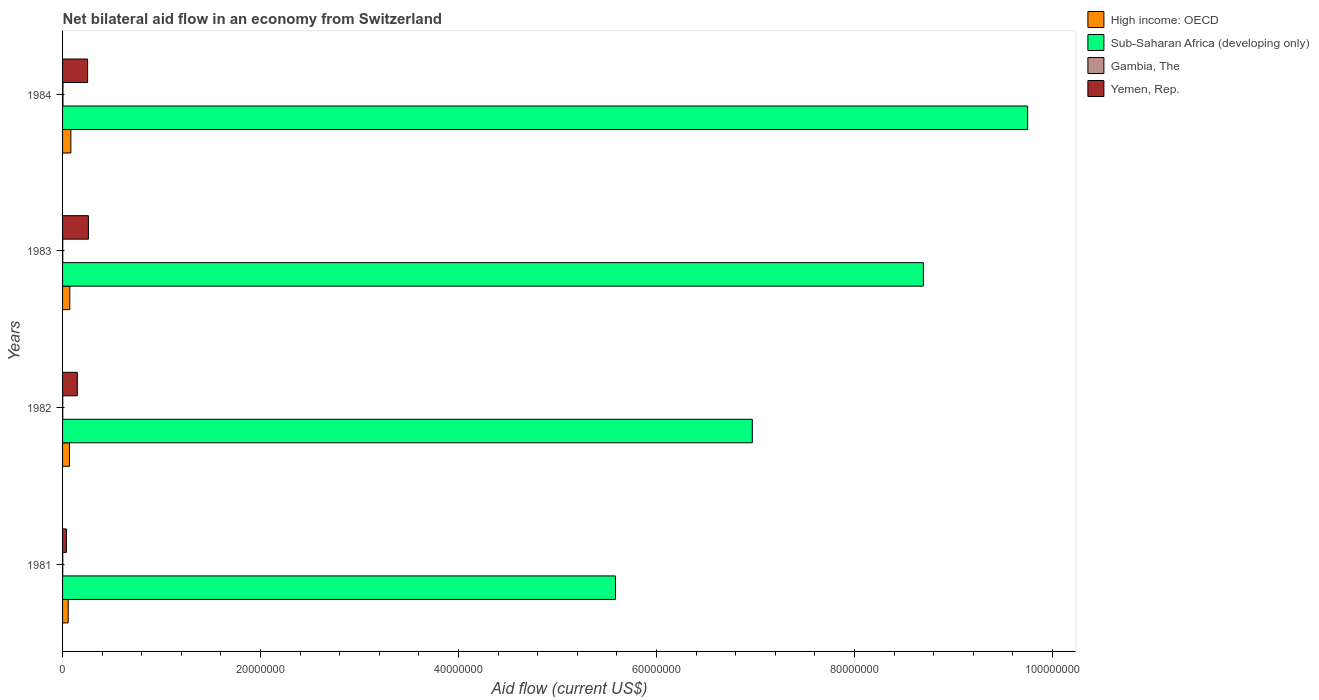How many groups of bars are there?
Provide a succinct answer. 4. Are the number of bars per tick equal to the number of legend labels?
Provide a short and direct response. Yes. Are the number of bars on each tick of the Y-axis equal?
Your answer should be very brief. Yes. How many bars are there on the 4th tick from the bottom?
Give a very brief answer. 4. What is the net bilateral aid flow in Sub-Saharan Africa (developing only) in 1982?
Keep it short and to the point. 6.97e+07. Across all years, what is the maximum net bilateral aid flow in Sub-Saharan Africa (developing only)?
Provide a succinct answer. 9.75e+07. Across all years, what is the minimum net bilateral aid flow in Sub-Saharan Africa (developing only)?
Give a very brief answer. 5.58e+07. In which year was the net bilateral aid flow in Yemen, Rep. maximum?
Your response must be concise. 1983. In which year was the net bilateral aid flow in Gambia, The minimum?
Make the answer very short. 1981. What is the total net bilateral aid flow in Yemen, Rep. in the graph?
Give a very brief answer. 7.02e+06. What is the difference between the net bilateral aid flow in Gambia, The in 1981 and that in 1983?
Your response must be concise. 0. What is the difference between the net bilateral aid flow in High income: OECD in 1981 and the net bilateral aid flow in Sub-Saharan Africa (developing only) in 1983?
Give a very brief answer. -8.64e+07. What is the average net bilateral aid flow in Gambia, The per year?
Ensure brevity in your answer.  2.50e+04. In the year 1983, what is the difference between the net bilateral aid flow in High income: OECD and net bilateral aid flow in Gambia, The?
Ensure brevity in your answer.  7.10e+05. In how many years, is the net bilateral aid flow in Sub-Saharan Africa (developing only) greater than 48000000 US$?
Provide a succinct answer. 4. What is the ratio of the net bilateral aid flow in High income: OECD in 1983 to that in 1984?
Provide a succinct answer. 0.87. What is the difference between the highest and the second highest net bilateral aid flow in Gambia, The?
Offer a very short reply. 2.00e+04. What is the difference between the highest and the lowest net bilateral aid flow in Yemen, Rep.?
Provide a succinct answer. 2.22e+06. Is the sum of the net bilateral aid flow in Yemen, Rep. in 1982 and 1983 greater than the maximum net bilateral aid flow in High income: OECD across all years?
Keep it short and to the point. Yes. What does the 1st bar from the top in 1982 represents?
Offer a terse response. Yemen, Rep. What does the 4th bar from the bottom in 1983 represents?
Give a very brief answer. Yemen, Rep. Is it the case that in every year, the sum of the net bilateral aid flow in High income: OECD and net bilateral aid flow in Gambia, The is greater than the net bilateral aid flow in Yemen, Rep.?
Provide a succinct answer. No. Are all the bars in the graph horizontal?
Give a very brief answer. Yes. Does the graph contain any zero values?
Offer a very short reply. No. Does the graph contain grids?
Provide a short and direct response. No. What is the title of the graph?
Offer a terse response. Net bilateral aid flow in an economy from Switzerland. Does "Marshall Islands" appear as one of the legend labels in the graph?
Provide a succinct answer. No. What is the label or title of the X-axis?
Give a very brief answer. Aid flow (current US$). What is the Aid flow (current US$) in High income: OECD in 1981?
Offer a very short reply. 5.70e+05. What is the Aid flow (current US$) in Sub-Saharan Africa (developing only) in 1981?
Offer a terse response. 5.58e+07. What is the Aid flow (current US$) of Yemen, Rep. in 1981?
Your answer should be very brief. 3.90e+05. What is the Aid flow (current US$) of Sub-Saharan Africa (developing only) in 1982?
Provide a short and direct response. 6.97e+07. What is the Aid flow (current US$) of Yemen, Rep. in 1982?
Your response must be concise. 1.49e+06. What is the Aid flow (current US$) in High income: OECD in 1983?
Provide a succinct answer. 7.30e+05. What is the Aid flow (current US$) of Sub-Saharan Africa (developing only) in 1983?
Make the answer very short. 8.70e+07. What is the Aid flow (current US$) of Gambia, The in 1983?
Keep it short and to the point. 2.00e+04. What is the Aid flow (current US$) in Yemen, Rep. in 1983?
Your answer should be compact. 2.61e+06. What is the Aid flow (current US$) in High income: OECD in 1984?
Keep it short and to the point. 8.40e+05. What is the Aid flow (current US$) of Sub-Saharan Africa (developing only) in 1984?
Make the answer very short. 9.75e+07. What is the Aid flow (current US$) of Yemen, Rep. in 1984?
Offer a terse response. 2.53e+06. Across all years, what is the maximum Aid flow (current US$) of High income: OECD?
Offer a very short reply. 8.40e+05. Across all years, what is the maximum Aid flow (current US$) in Sub-Saharan Africa (developing only)?
Your answer should be compact. 9.75e+07. Across all years, what is the maximum Aid flow (current US$) of Yemen, Rep.?
Give a very brief answer. 2.61e+06. Across all years, what is the minimum Aid flow (current US$) of High income: OECD?
Provide a short and direct response. 5.70e+05. Across all years, what is the minimum Aid flow (current US$) of Sub-Saharan Africa (developing only)?
Ensure brevity in your answer.  5.58e+07. What is the total Aid flow (current US$) of High income: OECD in the graph?
Ensure brevity in your answer.  2.84e+06. What is the total Aid flow (current US$) of Sub-Saharan Africa (developing only) in the graph?
Provide a succinct answer. 3.10e+08. What is the total Aid flow (current US$) in Gambia, The in the graph?
Offer a terse response. 1.00e+05. What is the total Aid flow (current US$) of Yemen, Rep. in the graph?
Make the answer very short. 7.02e+06. What is the difference between the Aid flow (current US$) in High income: OECD in 1981 and that in 1982?
Offer a very short reply. -1.30e+05. What is the difference between the Aid flow (current US$) in Sub-Saharan Africa (developing only) in 1981 and that in 1982?
Provide a short and direct response. -1.38e+07. What is the difference between the Aid flow (current US$) of Yemen, Rep. in 1981 and that in 1982?
Ensure brevity in your answer.  -1.10e+06. What is the difference between the Aid flow (current US$) of High income: OECD in 1981 and that in 1983?
Your response must be concise. -1.60e+05. What is the difference between the Aid flow (current US$) in Sub-Saharan Africa (developing only) in 1981 and that in 1983?
Make the answer very short. -3.11e+07. What is the difference between the Aid flow (current US$) in Yemen, Rep. in 1981 and that in 1983?
Provide a succinct answer. -2.22e+06. What is the difference between the Aid flow (current US$) in High income: OECD in 1981 and that in 1984?
Give a very brief answer. -2.70e+05. What is the difference between the Aid flow (current US$) of Sub-Saharan Africa (developing only) in 1981 and that in 1984?
Give a very brief answer. -4.16e+07. What is the difference between the Aid flow (current US$) of Gambia, The in 1981 and that in 1984?
Give a very brief answer. -2.00e+04. What is the difference between the Aid flow (current US$) in Yemen, Rep. in 1981 and that in 1984?
Your response must be concise. -2.14e+06. What is the difference between the Aid flow (current US$) in Sub-Saharan Africa (developing only) in 1982 and that in 1983?
Give a very brief answer. -1.73e+07. What is the difference between the Aid flow (current US$) of Gambia, The in 1982 and that in 1983?
Keep it short and to the point. 0. What is the difference between the Aid flow (current US$) in Yemen, Rep. in 1982 and that in 1983?
Ensure brevity in your answer.  -1.12e+06. What is the difference between the Aid flow (current US$) of Sub-Saharan Africa (developing only) in 1982 and that in 1984?
Offer a very short reply. -2.78e+07. What is the difference between the Aid flow (current US$) of Yemen, Rep. in 1982 and that in 1984?
Your answer should be very brief. -1.04e+06. What is the difference between the Aid flow (current US$) of Sub-Saharan Africa (developing only) in 1983 and that in 1984?
Your response must be concise. -1.05e+07. What is the difference between the Aid flow (current US$) in High income: OECD in 1981 and the Aid flow (current US$) in Sub-Saharan Africa (developing only) in 1982?
Give a very brief answer. -6.91e+07. What is the difference between the Aid flow (current US$) of High income: OECD in 1981 and the Aid flow (current US$) of Gambia, The in 1982?
Provide a short and direct response. 5.50e+05. What is the difference between the Aid flow (current US$) of High income: OECD in 1981 and the Aid flow (current US$) of Yemen, Rep. in 1982?
Provide a short and direct response. -9.20e+05. What is the difference between the Aid flow (current US$) of Sub-Saharan Africa (developing only) in 1981 and the Aid flow (current US$) of Gambia, The in 1982?
Your response must be concise. 5.58e+07. What is the difference between the Aid flow (current US$) in Sub-Saharan Africa (developing only) in 1981 and the Aid flow (current US$) in Yemen, Rep. in 1982?
Give a very brief answer. 5.44e+07. What is the difference between the Aid flow (current US$) in Gambia, The in 1981 and the Aid flow (current US$) in Yemen, Rep. in 1982?
Give a very brief answer. -1.47e+06. What is the difference between the Aid flow (current US$) in High income: OECD in 1981 and the Aid flow (current US$) in Sub-Saharan Africa (developing only) in 1983?
Provide a succinct answer. -8.64e+07. What is the difference between the Aid flow (current US$) of High income: OECD in 1981 and the Aid flow (current US$) of Gambia, The in 1983?
Give a very brief answer. 5.50e+05. What is the difference between the Aid flow (current US$) of High income: OECD in 1981 and the Aid flow (current US$) of Yemen, Rep. in 1983?
Offer a terse response. -2.04e+06. What is the difference between the Aid flow (current US$) in Sub-Saharan Africa (developing only) in 1981 and the Aid flow (current US$) in Gambia, The in 1983?
Provide a short and direct response. 5.58e+07. What is the difference between the Aid flow (current US$) in Sub-Saharan Africa (developing only) in 1981 and the Aid flow (current US$) in Yemen, Rep. in 1983?
Keep it short and to the point. 5.32e+07. What is the difference between the Aid flow (current US$) in Gambia, The in 1981 and the Aid flow (current US$) in Yemen, Rep. in 1983?
Provide a succinct answer. -2.59e+06. What is the difference between the Aid flow (current US$) in High income: OECD in 1981 and the Aid flow (current US$) in Sub-Saharan Africa (developing only) in 1984?
Ensure brevity in your answer.  -9.69e+07. What is the difference between the Aid flow (current US$) in High income: OECD in 1981 and the Aid flow (current US$) in Gambia, The in 1984?
Keep it short and to the point. 5.30e+05. What is the difference between the Aid flow (current US$) of High income: OECD in 1981 and the Aid flow (current US$) of Yemen, Rep. in 1984?
Your answer should be very brief. -1.96e+06. What is the difference between the Aid flow (current US$) of Sub-Saharan Africa (developing only) in 1981 and the Aid flow (current US$) of Gambia, The in 1984?
Give a very brief answer. 5.58e+07. What is the difference between the Aid flow (current US$) of Sub-Saharan Africa (developing only) in 1981 and the Aid flow (current US$) of Yemen, Rep. in 1984?
Make the answer very short. 5.33e+07. What is the difference between the Aid flow (current US$) of Gambia, The in 1981 and the Aid flow (current US$) of Yemen, Rep. in 1984?
Your response must be concise. -2.51e+06. What is the difference between the Aid flow (current US$) in High income: OECD in 1982 and the Aid flow (current US$) in Sub-Saharan Africa (developing only) in 1983?
Offer a terse response. -8.62e+07. What is the difference between the Aid flow (current US$) of High income: OECD in 1982 and the Aid flow (current US$) of Gambia, The in 1983?
Your answer should be very brief. 6.80e+05. What is the difference between the Aid flow (current US$) in High income: OECD in 1982 and the Aid flow (current US$) in Yemen, Rep. in 1983?
Your response must be concise. -1.91e+06. What is the difference between the Aid flow (current US$) in Sub-Saharan Africa (developing only) in 1982 and the Aid flow (current US$) in Gambia, The in 1983?
Your response must be concise. 6.96e+07. What is the difference between the Aid flow (current US$) of Sub-Saharan Africa (developing only) in 1982 and the Aid flow (current US$) of Yemen, Rep. in 1983?
Keep it short and to the point. 6.71e+07. What is the difference between the Aid flow (current US$) in Gambia, The in 1982 and the Aid flow (current US$) in Yemen, Rep. in 1983?
Your answer should be very brief. -2.59e+06. What is the difference between the Aid flow (current US$) in High income: OECD in 1982 and the Aid flow (current US$) in Sub-Saharan Africa (developing only) in 1984?
Provide a succinct answer. -9.68e+07. What is the difference between the Aid flow (current US$) in High income: OECD in 1982 and the Aid flow (current US$) in Gambia, The in 1984?
Offer a very short reply. 6.60e+05. What is the difference between the Aid flow (current US$) in High income: OECD in 1982 and the Aid flow (current US$) in Yemen, Rep. in 1984?
Your response must be concise. -1.83e+06. What is the difference between the Aid flow (current US$) in Sub-Saharan Africa (developing only) in 1982 and the Aid flow (current US$) in Gambia, The in 1984?
Your answer should be very brief. 6.96e+07. What is the difference between the Aid flow (current US$) in Sub-Saharan Africa (developing only) in 1982 and the Aid flow (current US$) in Yemen, Rep. in 1984?
Your answer should be very brief. 6.71e+07. What is the difference between the Aid flow (current US$) of Gambia, The in 1982 and the Aid flow (current US$) of Yemen, Rep. in 1984?
Your response must be concise. -2.51e+06. What is the difference between the Aid flow (current US$) of High income: OECD in 1983 and the Aid flow (current US$) of Sub-Saharan Africa (developing only) in 1984?
Provide a short and direct response. -9.68e+07. What is the difference between the Aid flow (current US$) in High income: OECD in 1983 and the Aid flow (current US$) in Gambia, The in 1984?
Your answer should be compact. 6.90e+05. What is the difference between the Aid flow (current US$) of High income: OECD in 1983 and the Aid flow (current US$) of Yemen, Rep. in 1984?
Keep it short and to the point. -1.80e+06. What is the difference between the Aid flow (current US$) in Sub-Saharan Africa (developing only) in 1983 and the Aid flow (current US$) in Gambia, The in 1984?
Your answer should be compact. 8.69e+07. What is the difference between the Aid flow (current US$) in Sub-Saharan Africa (developing only) in 1983 and the Aid flow (current US$) in Yemen, Rep. in 1984?
Give a very brief answer. 8.44e+07. What is the difference between the Aid flow (current US$) in Gambia, The in 1983 and the Aid flow (current US$) in Yemen, Rep. in 1984?
Make the answer very short. -2.51e+06. What is the average Aid flow (current US$) in High income: OECD per year?
Offer a terse response. 7.10e+05. What is the average Aid flow (current US$) in Sub-Saharan Africa (developing only) per year?
Your answer should be compact. 7.75e+07. What is the average Aid flow (current US$) of Gambia, The per year?
Offer a terse response. 2.50e+04. What is the average Aid flow (current US$) in Yemen, Rep. per year?
Ensure brevity in your answer.  1.76e+06. In the year 1981, what is the difference between the Aid flow (current US$) of High income: OECD and Aid flow (current US$) of Sub-Saharan Africa (developing only)?
Make the answer very short. -5.53e+07. In the year 1981, what is the difference between the Aid flow (current US$) in High income: OECD and Aid flow (current US$) in Gambia, The?
Offer a terse response. 5.50e+05. In the year 1981, what is the difference between the Aid flow (current US$) of High income: OECD and Aid flow (current US$) of Yemen, Rep.?
Keep it short and to the point. 1.80e+05. In the year 1981, what is the difference between the Aid flow (current US$) in Sub-Saharan Africa (developing only) and Aid flow (current US$) in Gambia, The?
Provide a succinct answer. 5.58e+07. In the year 1981, what is the difference between the Aid flow (current US$) of Sub-Saharan Africa (developing only) and Aid flow (current US$) of Yemen, Rep.?
Offer a terse response. 5.55e+07. In the year 1981, what is the difference between the Aid flow (current US$) in Gambia, The and Aid flow (current US$) in Yemen, Rep.?
Keep it short and to the point. -3.70e+05. In the year 1982, what is the difference between the Aid flow (current US$) of High income: OECD and Aid flow (current US$) of Sub-Saharan Africa (developing only)?
Offer a very short reply. -6.90e+07. In the year 1982, what is the difference between the Aid flow (current US$) in High income: OECD and Aid flow (current US$) in Gambia, The?
Provide a succinct answer. 6.80e+05. In the year 1982, what is the difference between the Aid flow (current US$) of High income: OECD and Aid flow (current US$) of Yemen, Rep.?
Your answer should be very brief. -7.90e+05. In the year 1982, what is the difference between the Aid flow (current US$) in Sub-Saharan Africa (developing only) and Aid flow (current US$) in Gambia, The?
Offer a terse response. 6.96e+07. In the year 1982, what is the difference between the Aid flow (current US$) in Sub-Saharan Africa (developing only) and Aid flow (current US$) in Yemen, Rep.?
Your response must be concise. 6.82e+07. In the year 1982, what is the difference between the Aid flow (current US$) in Gambia, The and Aid flow (current US$) in Yemen, Rep.?
Offer a terse response. -1.47e+06. In the year 1983, what is the difference between the Aid flow (current US$) of High income: OECD and Aid flow (current US$) of Sub-Saharan Africa (developing only)?
Keep it short and to the point. -8.62e+07. In the year 1983, what is the difference between the Aid flow (current US$) in High income: OECD and Aid flow (current US$) in Gambia, The?
Ensure brevity in your answer.  7.10e+05. In the year 1983, what is the difference between the Aid flow (current US$) in High income: OECD and Aid flow (current US$) in Yemen, Rep.?
Keep it short and to the point. -1.88e+06. In the year 1983, what is the difference between the Aid flow (current US$) of Sub-Saharan Africa (developing only) and Aid flow (current US$) of Gambia, The?
Offer a very short reply. 8.69e+07. In the year 1983, what is the difference between the Aid flow (current US$) in Sub-Saharan Africa (developing only) and Aid flow (current US$) in Yemen, Rep.?
Your answer should be very brief. 8.43e+07. In the year 1983, what is the difference between the Aid flow (current US$) in Gambia, The and Aid flow (current US$) in Yemen, Rep.?
Your answer should be very brief. -2.59e+06. In the year 1984, what is the difference between the Aid flow (current US$) of High income: OECD and Aid flow (current US$) of Sub-Saharan Africa (developing only)?
Make the answer very short. -9.66e+07. In the year 1984, what is the difference between the Aid flow (current US$) in High income: OECD and Aid flow (current US$) in Gambia, The?
Provide a short and direct response. 8.00e+05. In the year 1984, what is the difference between the Aid flow (current US$) of High income: OECD and Aid flow (current US$) of Yemen, Rep.?
Provide a short and direct response. -1.69e+06. In the year 1984, what is the difference between the Aid flow (current US$) of Sub-Saharan Africa (developing only) and Aid flow (current US$) of Gambia, The?
Offer a terse response. 9.74e+07. In the year 1984, what is the difference between the Aid flow (current US$) in Sub-Saharan Africa (developing only) and Aid flow (current US$) in Yemen, Rep.?
Offer a very short reply. 9.50e+07. In the year 1984, what is the difference between the Aid flow (current US$) of Gambia, The and Aid flow (current US$) of Yemen, Rep.?
Offer a terse response. -2.49e+06. What is the ratio of the Aid flow (current US$) in High income: OECD in 1981 to that in 1982?
Ensure brevity in your answer.  0.81. What is the ratio of the Aid flow (current US$) of Sub-Saharan Africa (developing only) in 1981 to that in 1982?
Offer a very short reply. 0.8. What is the ratio of the Aid flow (current US$) in Gambia, The in 1981 to that in 1982?
Ensure brevity in your answer.  1. What is the ratio of the Aid flow (current US$) of Yemen, Rep. in 1981 to that in 1982?
Give a very brief answer. 0.26. What is the ratio of the Aid flow (current US$) in High income: OECD in 1981 to that in 1983?
Provide a succinct answer. 0.78. What is the ratio of the Aid flow (current US$) in Sub-Saharan Africa (developing only) in 1981 to that in 1983?
Ensure brevity in your answer.  0.64. What is the ratio of the Aid flow (current US$) in Gambia, The in 1981 to that in 1983?
Offer a terse response. 1. What is the ratio of the Aid flow (current US$) in Yemen, Rep. in 1981 to that in 1983?
Offer a terse response. 0.15. What is the ratio of the Aid flow (current US$) in High income: OECD in 1981 to that in 1984?
Your response must be concise. 0.68. What is the ratio of the Aid flow (current US$) in Sub-Saharan Africa (developing only) in 1981 to that in 1984?
Keep it short and to the point. 0.57. What is the ratio of the Aid flow (current US$) in Yemen, Rep. in 1981 to that in 1984?
Provide a short and direct response. 0.15. What is the ratio of the Aid flow (current US$) of High income: OECD in 1982 to that in 1983?
Provide a short and direct response. 0.96. What is the ratio of the Aid flow (current US$) of Sub-Saharan Africa (developing only) in 1982 to that in 1983?
Keep it short and to the point. 0.8. What is the ratio of the Aid flow (current US$) in Yemen, Rep. in 1982 to that in 1983?
Your answer should be compact. 0.57. What is the ratio of the Aid flow (current US$) of High income: OECD in 1982 to that in 1984?
Keep it short and to the point. 0.83. What is the ratio of the Aid flow (current US$) of Sub-Saharan Africa (developing only) in 1982 to that in 1984?
Ensure brevity in your answer.  0.71. What is the ratio of the Aid flow (current US$) in Gambia, The in 1982 to that in 1984?
Your answer should be very brief. 0.5. What is the ratio of the Aid flow (current US$) of Yemen, Rep. in 1982 to that in 1984?
Provide a succinct answer. 0.59. What is the ratio of the Aid flow (current US$) of High income: OECD in 1983 to that in 1984?
Ensure brevity in your answer.  0.87. What is the ratio of the Aid flow (current US$) in Sub-Saharan Africa (developing only) in 1983 to that in 1984?
Ensure brevity in your answer.  0.89. What is the ratio of the Aid flow (current US$) of Yemen, Rep. in 1983 to that in 1984?
Make the answer very short. 1.03. What is the difference between the highest and the second highest Aid flow (current US$) in Sub-Saharan Africa (developing only)?
Provide a succinct answer. 1.05e+07. What is the difference between the highest and the lowest Aid flow (current US$) of Sub-Saharan Africa (developing only)?
Offer a terse response. 4.16e+07. What is the difference between the highest and the lowest Aid flow (current US$) in Yemen, Rep.?
Your response must be concise. 2.22e+06. 